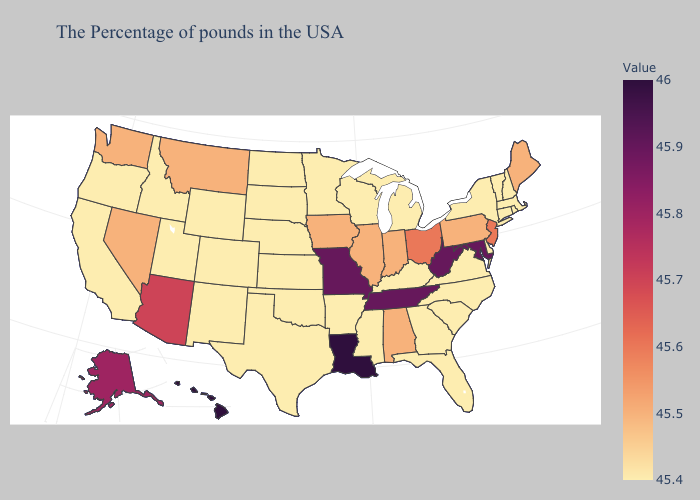Which states have the lowest value in the South?
Give a very brief answer. Delaware, Virginia, North Carolina, South Carolina, Florida, Georgia, Kentucky, Mississippi, Arkansas, Oklahoma, Texas. Among the states that border Alabama , does Florida have the highest value?
Give a very brief answer. No. Which states have the lowest value in the South?
Quick response, please. Delaware, Virginia, North Carolina, South Carolina, Florida, Georgia, Kentucky, Mississippi, Arkansas, Oklahoma, Texas. Does Maryland have the highest value in the South?
Write a very short answer. No. Among the states that border Georgia , does Tennessee have the highest value?
Quick response, please. Yes. 